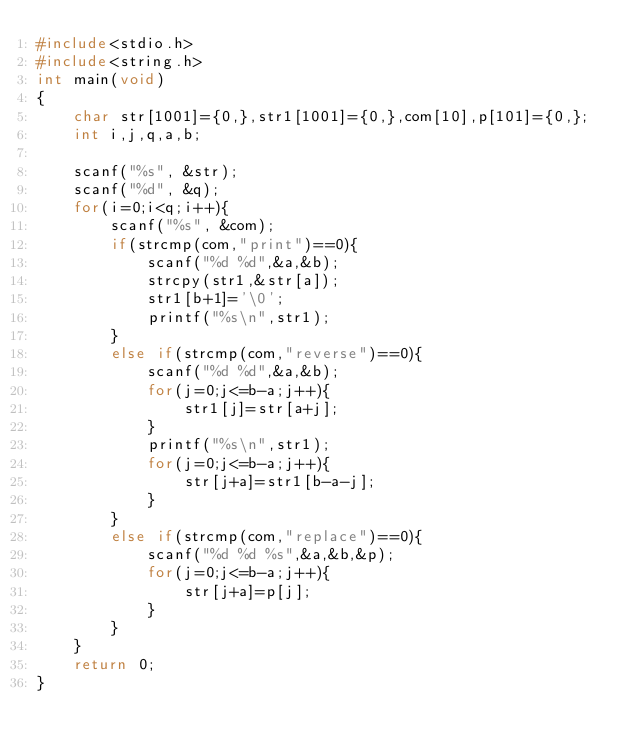<code> <loc_0><loc_0><loc_500><loc_500><_C_>#include<stdio.h>
#include<string.h>
int main(void)
{
	char str[1001]={0,},str1[1001]={0,},com[10],p[101]={0,};
	int i,j,q,a,b;
    
	scanf("%s", &str);
	scanf("%d", &q);
	for(i=0;i<q;i++){
		scanf("%s", &com);
		if(strcmp(com,"print")==0){
			scanf("%d %d",&a,&b);
			strcpy(str1,&str[a]);
			str1[b+1]='\0';
			printf("%s\n",str1);
		}
		else if(strcmp(com,"reverse")==0){
			scanf("%d %d",&a,&b);
			for(j=0;j<=b-a;j++){
				str1[j]=str[a+j];
			}
			printf("%s\n",str1);
			for(j=0;j<=b-a;j++){
				str[j+a]=str1[b-a-j];
			}
		}
		else if(strcmp(com,"replace")==0){
			scanf("%d %d %s",&a,&b,&p);
			for(j=0;j<=b-a;j++){
				str[j+a]=p[j];
			}
		}
	}
	return 0;   
}</code> 